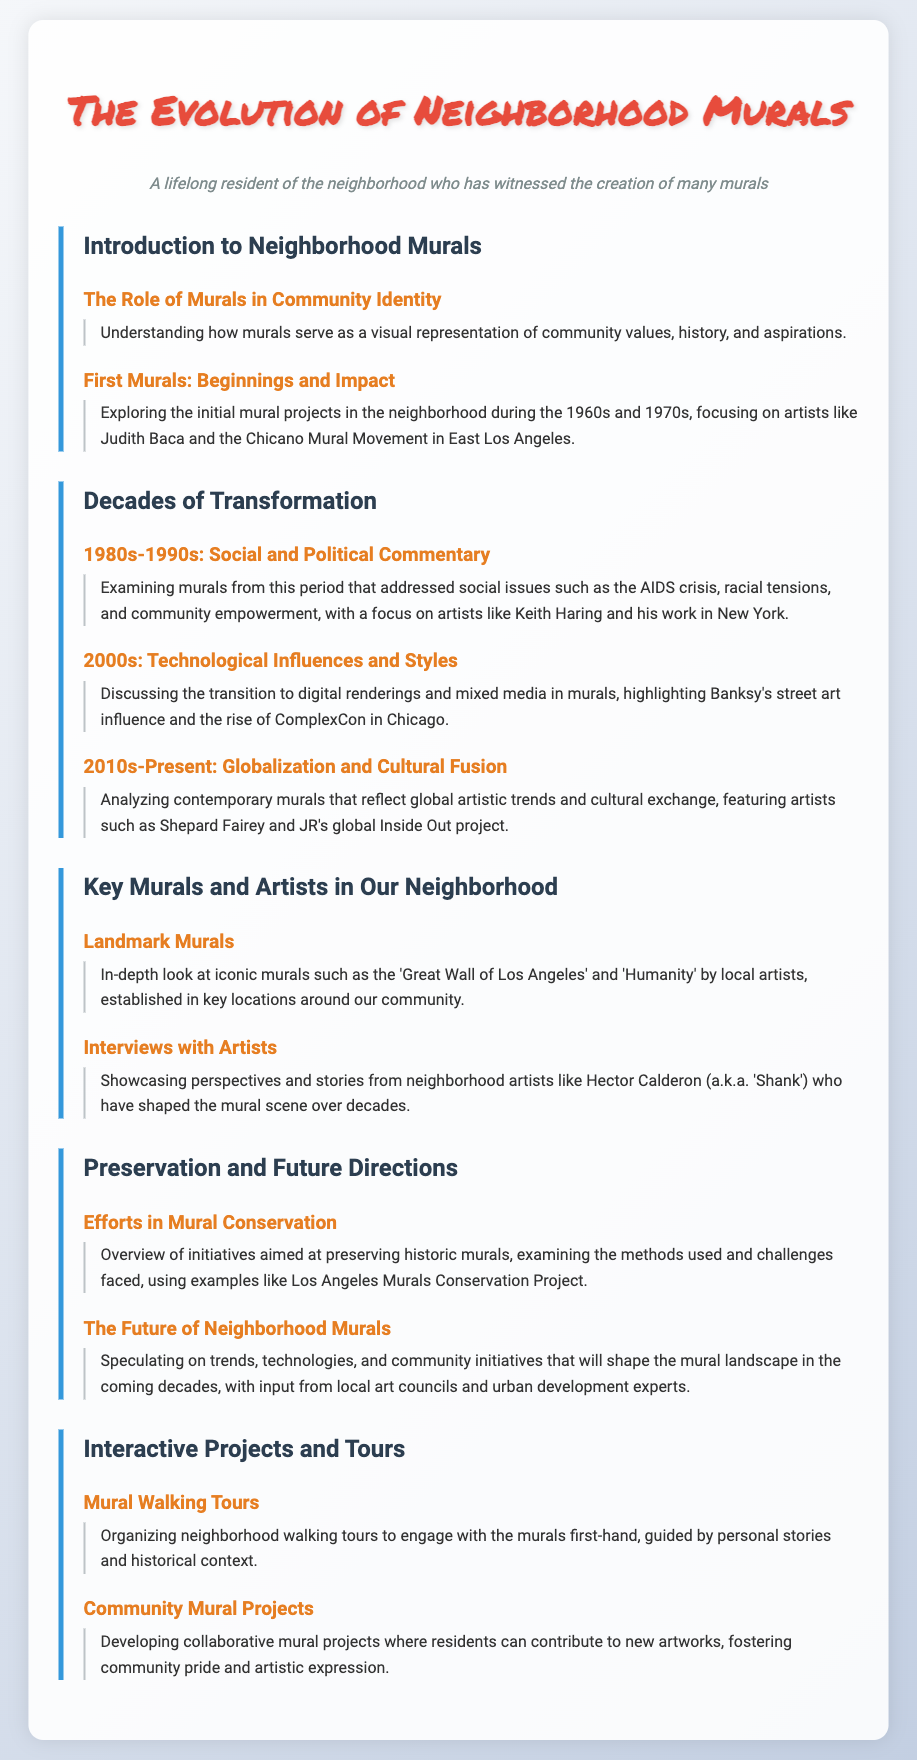what is the title of the syllabus? The title is presented prominently at the top of the document.
Answer: The Evolution of Neighborhood Murals who are two artists mentioned in the syllabus? The syllabus lists specific artists associated with different mural movements.
Answer: Judith Baca and Keith Haring what decade is associated with the initial mural projects in the neighborhood? The initial mural projects are discussed in the context of specific decades.
Answer: 1960s and 1970s which social issue is highlighted in the murals of the 1980s-1990s? The syllabus indicates that murals from this period addressed significant social issues.
Answer: AIDS crisis what is one method mentioned for preserving historic murals? The syllabus outlines various initiatives aimed at preservation.
Answer: Los Angeles Murals Conservation Project what type of community initiative is proposed in the syllabus? The document discusses types of projects aimed at fostering community engagement.
Answer: Community Mural Projects what are participants encouraged to do on mural walking tours? The syllabus specifies the activities involved in the walking tours.
Answer: Engage with the murals first-hand who is referred to by the name 'Shank' in the syllabus? The syllabus includes specific artists who have contributed to the mural scene.
Answer: Hector Calderon 